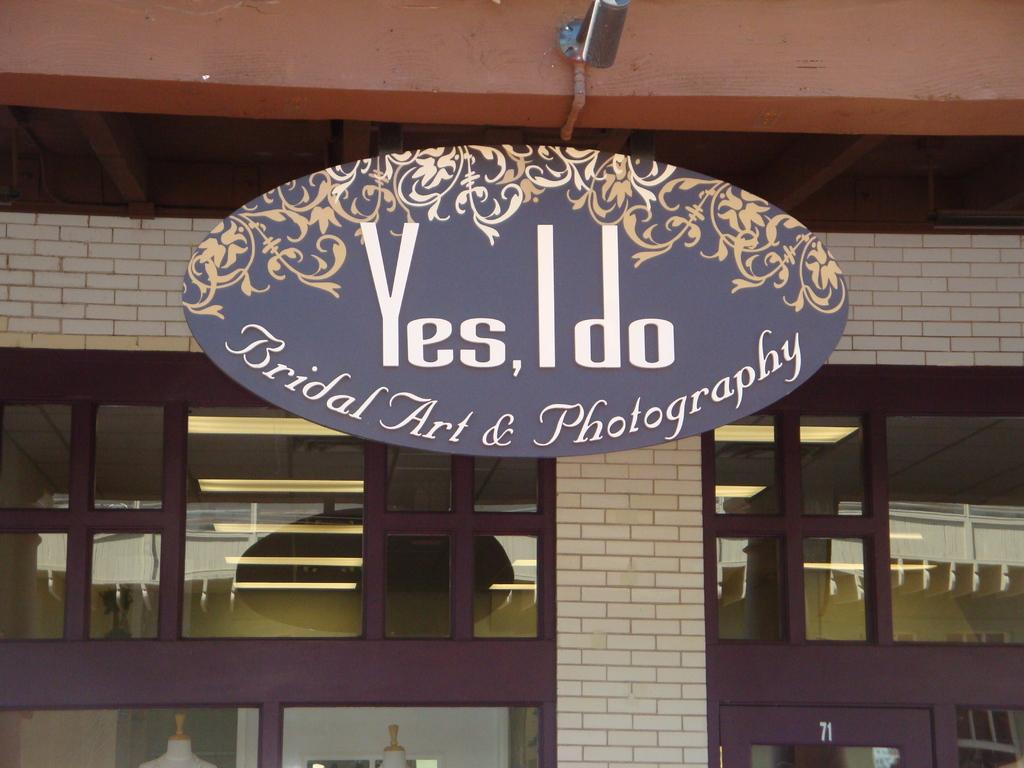<image>
Write a terse but informative summary of the picture. Yes I do bridal art and photography sign in front of a building 